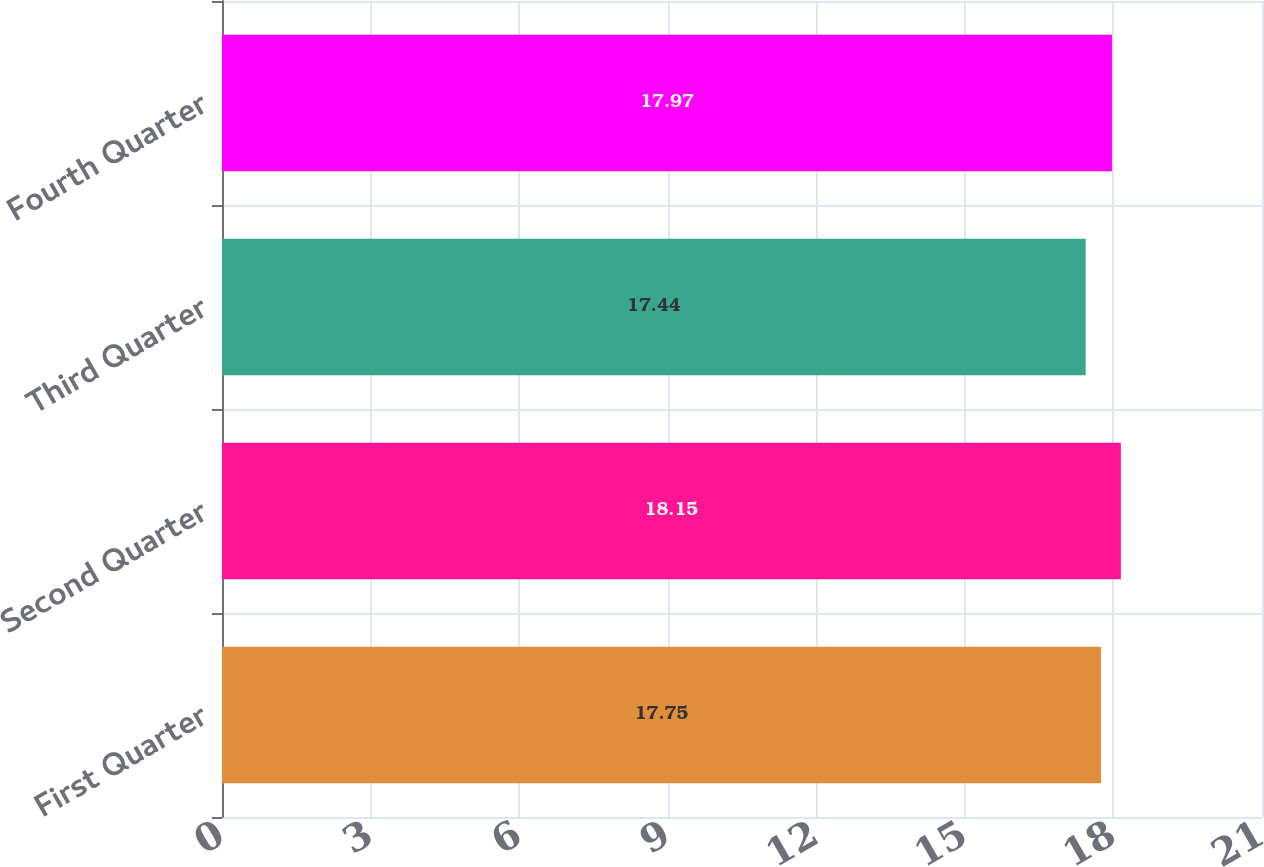<chart> <loc_0><loc_0><loc_500><loc_500><bar_chart><fcel>First Quarter<fcel>Second Quarter<fcel>Third Quarter<fcel>Fourth Quarter<nl><fcel>17.75<fcel>18.15<fcel>17.44<fcel>17.97<nl></chart> 